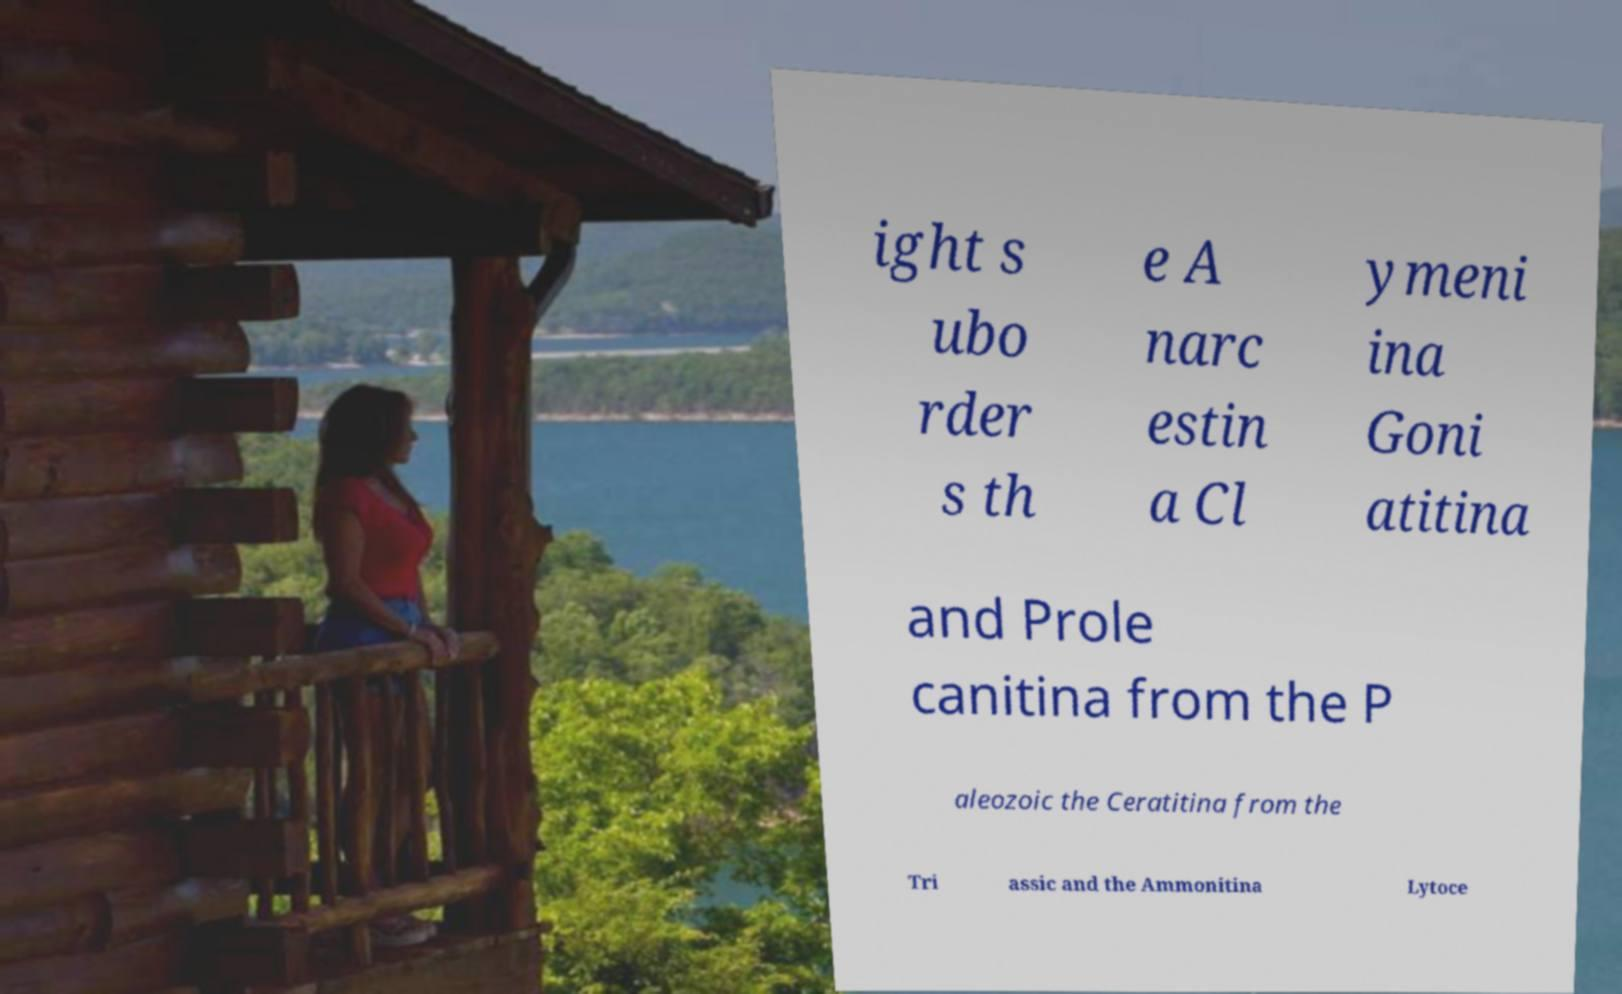Please read and relay the text visible in this image. What does it say? ight s ubo rder s th e A narc estin a Cl ymeni ina Goni atitina and Prole canitina from the P aleozoic the Ceratitina from the Tri assic and the Ammonitina Lytoce 